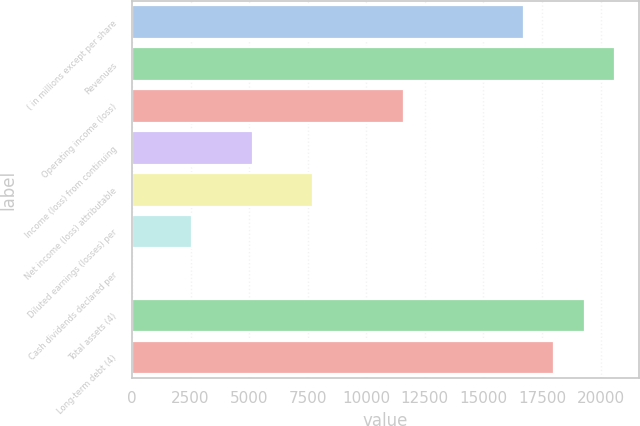Convert chart. <chart><loc_0><loc_0><loc_500><loc_500><bar_chart><fcel>( in millions except per share<fcel>Revenues<fcel>Operating income (loss)<fcel>Income (loss) from continuing<fcel>Net income (loss) attributable<fcel>Diluted earnings (losses) per<fcel>Cash dividends declared per<fcel>Total assets (4)<fcel>Long-term debt (4)<nl><fcel>16742.6<fcel>20606.2<fcel>11591.2<fcel>5151.81<fcel>7727.55<fcel>2576.07<fcel>0.33<fcel>19318.4<fcel>18030.5<nl></chart> 